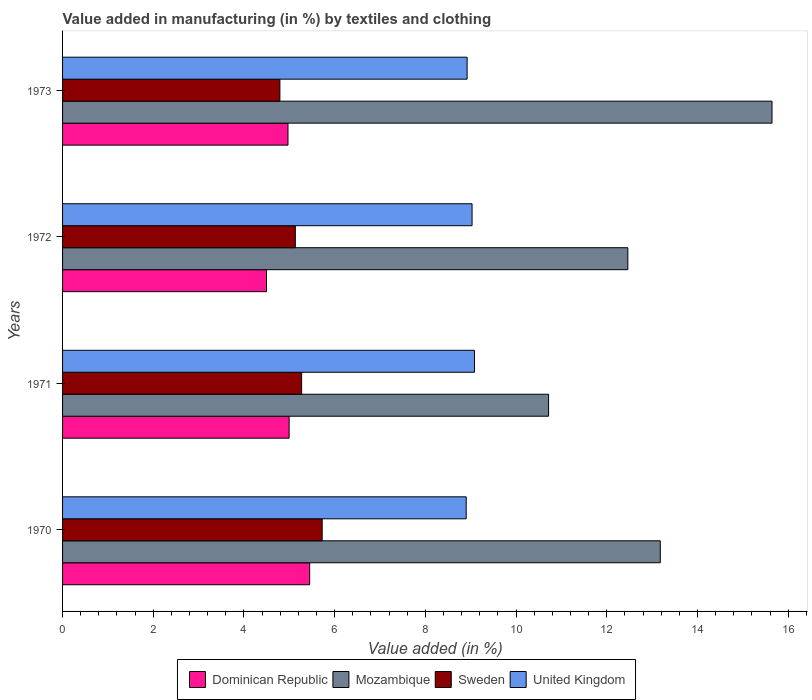How many different coloured bars are there?
Provide a succinct answer. 4. How many groups of bars are there?
Make the answer very short. 4. Are the number of bars per tick equal to the number of legend labels?
Offer a very short reply. Yes. Are the number of bars on each tick of the Y-axis equal?
Provide a succinct answer. Yes. What is the percentage of value added in manufacturing by textiles and clothing in Mozambique in 1972?
Ensure brevity in your answer.  12.46. Across all years, what is the maximum percentage of value added in manufacturing by textiles and clothing in United Kingdom?
Ensure brevity in your answer.  9.08. Across all years, what is the minimum percentage of value added in manufacturing by textiles and clothing in Mozambique?
Keep it short and to the point. 10.72. What is the total percentage of value added in manufacturing by textiles and clothing in Sweden in the graph?
Your answer should be compact. 20.92. What is the difference between the percentage of value added in manufacturing by textiles and clothing in United Kingdom in 1972 and that in 1973?
Your answer should be very brief. 0.11. What is the difference between the percentage of value added in manufacturing by textiles and clothing in United Kingdom in 1971 and the percentage of value added in manufacturing by textiles and clothing in Mozambique in 1972?
Give a very brief answer. -3.38. What is the average percentage of value added in manufacturing by textiles and clothing in United Kingdom per year?
Provide a succinct answer. 8.98. In the year 1970, what is the difference between the percentage of value added in manufacturing by textiles and clothing in Mozambique and percentage of value added in manufacturing by textiles and clothing in United Kingdom?
Ensure brevity in your answer.  4.28. In how many years, is the percentage of value added in manufacturing by textiles and clothing in Mozambique greater than 6 %?
Give a very brief answer. 4. What is the ratio of the percentage of value added in manufacturing by textiles and clothing in Mozambique in 1971 to that in 1972?
Your response must be concise. 0.86. What is the difference between the highest and the second highest percentage of value added in manufacturing by textiles and clothing in Dominican Republic?
Offer a very short reply. 0.45. What is the difference between the highest and the lowest percentage of value added in manufacturing by textiles and clothing in Sweden?
Your answer should be compact. 0.93. What does the 1st bar from the bottom in 1970 represents?
Give a very brief answer. Dominican Republic. Is it the case that in every year, the sum of the percentage of value added in manufacturing by textiles and clothing in Dominican Republic and percentage of value added in manufacturing by textiles and clothing in Sweden is greater than the percentage of value added in manufacturing by textiles and clothing in Mozambique?
Give a very brief answer. No. Are all the bars in the graph horizontal?
Ensure brevity in your answer.  Yes. How many years are there in the graph?
Ensure brevity in your answer.  4. Are the values on the major ticks of X-axis written in scientific E-notation?
Offer a terse response. No. Does the graph contain grids?
Provide a short and direct response. No. How many legend labels are there?
Provide a succinct answer. 4. How are the legend labels stacked?
Your answer should be compact. Horizontal. What is the title of the graph?
Give a very brief answer. Value added in manufacturing (in %) by textiles and clothing. What is the label or title of the X-axis?
Give a very brief answer. Value added (in %). What is the Value added (in %) in Dominican Republic in 1970?
Offer a terse response. 5.45. What is the Value added (in %) of Mozambique in 1970?
Give a very brief answer. 13.18. What is the Value added (in %) of Sweden in 1970?
Provide a succinct answer. 5.72. What is the Value added (in %) in United Kingdom in 1970?
Provide a succinct answer. 8.9. What is the Value added (in %) in Dominican Republic in 1971?
Keep it short and to the point. 5. What is the Value added (in %) in Mozambique in 1971?
Keep it short and to the point. 10.72. What is the Value added (in %) of Sweden in 1971?
Give a very brief answer. 5.27. What is the Value added (in %) in United Kingdom in 1971?
Make the answer very short. 9.08. What is the Value added (in %) of Dominican Republic in 1972?
Provide a succinct answer. 4.5. What is the Value added (in %) in Mozambique in 1972?
Offer a very short reply. 12.46. What is the Value added (in %) of Sweden in 1972?
Make the answer very short. 5.13. What is the Value added (in %) in United Kingdom in 1972?
Offer a terse response. 9.03. What is the Value added (in %) in Dominican Republic in 1973?
Offer a very short reply. 4.97. What is the Value added (in %) in Mozambique in 1973?
Your response must be concise. 15.64. What is the Value added (in %) of Sweden in 1973?
Offer a terse response. 4.79. What is the Value added (in %) in United Kingdom in 1973?
Make the answer very short. 8.92. Across all years, what is the maximum Value added (in %) of Dominican Republic?
Offer a very short reply. 5.45. Across all years, what is the maximum Value added (in %) of Mozambique?
Provide a short and direct response. 15.64. Across all years, what is the maximum Value added (in %) of Sweden?
Provide a short and direct response. 5.72. Across all years, what is the maximum Value added (in %) in United Kingdom?
Provide a short and direct response. 9.08. Across all years, what is the minimum Value added (in %) of Dominican Republic?
Keep it short and to the point. 4.5. Across all years, what is the minimum Value added (in %) in Mozambique?
Offer a terse response. 10.72. Across all years, what is the minimum Value added (in %) of Sweden?
Your answer should be compact. 4.79. Across all years, what is the minimum Value added (in %) of United Kingdom?
Provide a short and direct response. 8.9. What is the total Value added (in %) in Dominican Republic in the graph?
Ensure brevity in your answer.  19.91. What is the total Value added (in %) in Mozambique in the graph?
Your response must be concise. 52. What is the total Value added (in %) in Sweden in the graph?
Offer a terse response. 20.92. What is the total Value added (in %) of United Kingdom in the graph?
Keep it short and to the point. 35.93. What is the difference between the Value added (in %) in Dominican Republic in 1970 and that in 1971?
Your answer should be very brief. 0.45. What is the difference between the Value added (in %) in Mozambique in 1970 and that in 1971?
Offer a very short reply. 2.46. What is the difference between the Value added (in %) in Sweden in 1970 and that in 1971?
Your answer should be compact. 0.45. What is the difference between the Value added (in %) in United Kingdom in 1970 and that in 1971?
Your answer should be compact. -0.18. What is the difference between the Value added (in %) in Dominican Republic in 1970 and that in 1972?
Your response must be concise. 0.95. What is the difference between the Value added (in %) of Mozambique in 1970 and that in 1972?
Provide a succinct answer. 0.71. What is the difference between the Value added (in %) in Sweden in 1970 and that in 1972?
Offer a very short reply. 0.59. What is the difference between the Value added (in %) of United Kingdom in 1970 and that in 1972?
Your answer should be compact. -0.13. What is the difference between the Value added (in %) in Dominican Republic in 1970 and that in 1973?
Provide a succinct answer. 0.48. What is the difference between the Value added (in %) in Mozambique in 1970 and that in 1973?
Offer a terse response. -2.46. What is the difference between the Value added (in %) in Sweden in 1970 and that in 1973?
Ensure brevity in your answer.  0.93. What is the difference between the Value added (in %) in United Kingdom in 1970 and that in 1973?
Offer a terse response. -0.02. What is the difference between the Value added (in %) in Dominican Republic in 1971 and that in 1972?
Make the answer very short. 0.5. What is the difference between the Value added (in %) of Mozambique in 1971 and that in 1972?
Your answer should be compact. -1.75. What is the difference between the Value added (in %) in Sweden in 1971 and that in 1972?
Make the answer very short. 0.14. What is the difference between the Value added (in %) of United Kingdom in 1971 and that in 1972?
Provide a succinct answer. 0.05. What is the difference between the Value added (in %) in Dominican Republic in 1971 and that in 1973?
Your answer should be compact. 0.03. What is the difference between the Value added (in %) of Mozambique in 1971 and that in 1973?
Keep it short and to the point. -4.93. What is the difference between the Value added (in %) of Sweden in 1971 and that in 1973?
Make the answer very short. 0.48. What is the difference between the Value added (in %) of United Kingdom in 1971 and that in 1973?
Ensure brevity in your answer.  0.16. What is the difference between the Value added (in %) in Dominican Republic in 1972 and that in 1973?
Ensure brevity in your answer.  -0.47. What is the difference between the Value added (in %) in Mozambique in 1972 and that in 1973?
Provide a short and direct response. -3.18. What is the difference between the Value added (in %) of Sweden in 1972 and that in 1973?
Offer a terse response. 0.34. What is the difference between the Value added (in %) of United Kingdom in 1972 and that in 1973?
Your answer should be compact. 0.11. What is the difference between the Value added (in %) of Dominican Republic in 1970 and the Value added (in %) of Mozambique in 1971?
Offer a very short reply. -5.27. What is the difference between the Value added (in %) of Dominican Republic in 1970 and the Value added (in %) of Sweden in 1971?
Your answer should be very brief. 0.18. What is the difference between the Value added (in %) in Dominican Republic in 1970 and the Value added (in %) in United Kingdom in 1971?
Ensure brevity in your answer.  -3.63. What is the difference between the Value added (in %) in Mozambique in 1970 and the Value added (in %) in Sweden in 1971?
Provide a succinct answer. 7.91. What is the difference between the Value added (in %) of Mozambique in 1970 and the Value added (in %) of United Kingdom in 1971?
Keep it short and to the point. 4.1. What is the difference between the Value added (in %) in Sweden in 1970 and the Value added (in %) in United Kingdom in 1971?
Make the answer very short. -3.36. What is the difference between the Value added (in %) in Dominican Republic in 1970 and the Value added (in %) in Mozambique in 1972?
Your answer should be very brief. -7.02. What is the difference between the Value added (in %) in Dominican Republic in 1970 and the Value added (in %) in Sweden in 1972?
Provide a short and direct response. 0.32. What is the difference between the Value added (in %) in Dominican Republic in 1970 and the Value added (in %) in United Kingdom in 1972?
Give a very brief answer. -3.58. What is the difference between the Value added (in %) of Mozambique in 1970 and the Value added (in %) of Sweden in 1972?
Provide a short and direct response. 8.05. What is the difference between the Value added (in %) in Mozambique in 1970 and the Value added (in %) in United Kingdom in 1972?
Provide a short and direct response. 4.15. What is the difference between the Value added (in %) of Sweden in 1970 and the Value added (in %) of United Kingdom in 1972?
Provide a short and direct response. -3.3. What is the difference between the Value added (in %) of Dominican Republic in 1970 and the Value added (in %) of Mozambique in 1973?
Keep it short and to the point. -10.19. What is the difference between the Value added (in %) of Dominican Republic in 1970 and the Value added (in %) of Sweden in 1973?
Your answer should be compact. 0.66. What is the difference between the Value added (in %) of Dominican Republic in 1970 and the Value added (in %) of United Kingdom in 1973?
Give a very brief answer. -3.47. What is the difference between the Value added (in %) of Mozambique in 1970 and the Value added (in %) of Sweden in 1973?
Ensure brevity in your answer.  8.39. What is the difference between the Value added (in %) of Mozambique in 1970 and the Value added (in %) of United Kingdom in 1973?
Provide a succinct answer. 4.26. What is the difference between the Value added (in %) in Sweden in 1970 and the Value added (in %) in United Kingdom in 1973?
Your response must be concise. -3.2. What is the difference between the Value added (in %) in Dominican Republic in 1971 and the Value added (in %) in Mozambique in 1972?
Your response must be concise. -7.47. What is the difference between the Value added (in %) in Dominican Republic in 1971 and the Value added (in %) in Sweden in 1972?
Make the answer very short. -0.14. What is the difference between the Value added (in %) of Dominican Republic in 1971 and the Value added (in %) of United Kingdom in 1972?
Provide a succinct answer. -4.03. What is the difference between the Value added (in %) of Mozambique in 1971 and the Value added (in %) of Sweden in 1972?
Give a very brief answer. 5.58. What is the difference between the Value added (in %) of Mozambique in 1971 and the Value added (in %) of United Kingdom in 1972?
Offer a very short reply. 1.69. What is the difference between the Value added (in %) in Sweden in 1971 and the Value added (in %) in United Kingdom in 1972?
Your answer should be compact. -3.76. What is the difference between the Value added (in %) in Dominican Republic in 1971 and the Value added (in %) in Mozambique in 1973?
Offer a terse response. -10.65. What is the difference between the Value added (in %) of Dominican Republic in 1971 and the Value added (in %) of Sweden in 1973?
Your answer should be very brief. 0.2. What is the difference between the Value added (in %) in Dominican Republic in 1971 and the Value added (in %) in United Kingdom in 1973?
Your answer should be compact. -3.92. What is the difference between the Value added (in %) in Mozambique in 1971 and the Value added (in %) in Sweden in 1973?
Keep it short and to the point. 5.92. What is the difference between the Value added (in %) in Mozambique in 1971 and the Value added (in %) in United Kingdom in 1973?
Ensure brevity in your answer.  1.8. What is the difference between the Value added (in %) of Sweden in 1971 and the Value added (in %) of United Kingdom in 1973?
Provide a short and direct response. -3.65. What is the difference between the Value added (in %) in Dominican Republic in 1972 and the Value added (in %) in Mozambique in 1973?
Give a very brief answer. -11.15. What is the difference between the Value added (in %) in Dominican Republic in 1972 and the Value added (in %) in Sweden in 1973?
Provide a short and direct response. -0.29. What is the difference between the Value added (in %) of Dominican Republic in 1972 and the Value added (in %) of United Kingdom in 1973?
Your response must be concise. -4.42. What is the difference between the Value added (in %) of Mozambique in 1972 and the Value added (in %) of Sweden in 1973?
Offer a very short reply. 7.67. What is the difference between the Value added (in %) of Mozambique in 1972 and the Value added (in %) of United Kingdom in 1973?
Your answer should be compact. 3.54. What is the difference between the Value added (in %) in Sweden in 1972 and the Value added (in %) in United Kingdom in 1973?
Give a very brief answer. -3.79. What is the average Value added (in %) in Dominican Republic per year?
Your answer should be very brief. 4.98. What is the average Value added (in %) in Mozambique per year?
Make the answer very short. 13. What is the average Value added (in %) of Sweden per year?
Make the answer very short. 5.23. What is the average Value added (in %) of United Kingdom per year?
Offer a terse response. 8.98. In the year 1970, what is the difference between the Value added (in %) of Dominican Republic and Value added (in %) of Mozambique?
Your answer should be compact. -7.73. In the year 1970, what is the difference between the Value added (in %) in Dominican Republic and Value added (in %) in Sweden?
Provide a short and direct response. -0.28. In the year 1970, what is the difference between the Value added (in %) of Dominican Republic and Value added (in %) of United Kingdom?
Offer a very short reply. -3.45. In the year 1970, what is the difference between the Value added (in %) of Mozambique and Value added (in %) of Sweden?
Your answer should be very brief. 7.45. In the year 1970, what is the difference between the Value added (in %) in Mozambique and Value added (in %) in United Kingdom?
Provide a short and direct response. 4.28. In the year 1970, what is the difference between the Value added (in %) in Sweden and Value added (in %) in United Kingdom?
Keep it short and to the point. -3.18. In the year 1971, what is the difference between the Value added (in %) in Dominican Republic and Value added (in %) in Mozambique?
Keep it short and to the point. -5.72. In the year 1971, what is the difference between the Value added (in %) in Dominican Republic and Value added (in %) in Sweden?
Your answer should be very brief. -0.28. In the year 1971, what is the difference between the Value added (in %) of Dominican Republic and Value added (in %) of United Kingdom?
Make the answer very short. -4.09. In the year 1971, what is the difference between the Value added (in %) in Mozambique and Value added (in %) in Sweden?
Give a very brief answer. 5.45. In the year 1971, what is the difference between the Value added (in %) in Mozambique and Value added (in %) in United Kingdom?
Offer a terse response. 1.63. In the year 1971, what is the difference between the Value added (in %) in Sweden and Value added (in %) in United Kingdom?
Provide a succinct answer. -3.81. In the year 1972, what is the difference between the Value added (in %) in Dominican Republic and Value added (in %) in Mozambique?
Offer a very short reply. -7.97. In the year 1972, what is the difference between the Value added (in %) of Dominican Republic and Value added (in %) of Sweden?
Provide a short and direct response. -0.64. In the year 1972, what is the difference between the Value added (in %) in Dominican Republic and Value added (in %) in United Kingdom?
Offer a terse response. -4.53. In the year 1972, what is the difference between the Value added (in %) of Mozambique and Value added (in %) of Sweden?
Offer a terse response. 7.33. In the year 1972, what is the difference between the Value added (in %) in Mozambique and Value added (in %) in United Kingdom?
Keep it short and to the point. 3.44. In the year 1972, what is the difference between the Value added (in %) in Sweden and Value added (in %) in United Kingdom?
Your response must be concise. -3.9. In the year 1973, what is the difference between the Value added (in %) of Dominican Republic and Value added (in %) of Mozambique?
Provide a short and direct response. -10.67. In the year 1973, what is the difference between the Value added (in %) in Dominican Republic and Value added (in %) in Sweden?
Give a very brief answer. 0.18. In the year 1973, what is the difference between the Value added (in %) of Dominican Republic and Value added (in %) of United Kingdom?
Ensure brevity in your answer.  -3.95. In the year 1973, what is the difference between the Value added (in %) in Mozambique and Value added (in %) in Sweden?
Ensure brevity in your answer.  10.85. In the year 1973, what is the difference between the Value added (in %) in Mozambique and Value added (in %) in United Kingdom?
Offer a terse response. 6.72. In the year 1973, what is the difference between the Value added (in %) of Sweden and Value added (in %) of United Kingdom?
Your answer should be compact. -4.13. What is the ratio of the Value added (in %) in Dominican Republic in 1970 to that in 1971?
Give a very brief answer. 1.09. What is the ratio of the Value added (in %) in Mozambique in 1970 to that in 1971?
Your answer should be very brief. 1.23. What is the ratio of the Value added (in %) of Sweden in 1970 to that in 1971?
Provide a succinct answer. 1.09. What is the ratio of the Value added (in %) of Dominican Republic in 1970 to that in 1972?
Your response must be concise. 1.21. What is the ratio of the Value added (in %) of Mozambique in 1970 to that in 1972?
Keep it short and to the point. 1.06. What is the ratio of the Value added (in %) of Sweden in 1970 to that in 1972?
Give a very brief answer. 1.12. What is the ratio of the Value added (in %) in United Kingdom in 1970 to that in 1972?
Provide a short and direct response. 0.99. What is the ratio of the Value added (in %) in Dominican Republic in 1970 to that in 1973?
Provide a short and direct response. 1.1. What is the ratio of the Value added (in %) of Mozambique in 1970 to that in 1973?
Make the answer very short. 0.84. What is the ratio of the Value added (in %) in Sweden in 1970 to that in 1973?
Offer a very short reply. 1.19. What is the ratio of the Value added (in %) of United Kingdom in 1970 to that in 1973?
Ensure brevity in your answer.  1. What is the ratio of the Value added (in %) of Dominican Republic in 1971 to that in 1972?
Offer a terse response. 1.11. What is the ratio of the Value added (in %) of Mozambique in 1971 to that in 1972?
Keep it short and to the point. 0.86. What is the ratio of the Value added (in %) in United Kingdom in 1971 to that in 1972?
Your answer should be compact. 1.01. What is the ratio of the Value added (in %) of Mozambique in 1971 to that in 1973?
Keep it short and to the point. 0.69. What is the ratio of the Value added (in %) of Sweden in 1971 to that in 1973?
Ensure brevity in your answer.  1.1. What is the ratio of the Value added (in %) of United Kingdom in 1971 to that in 1973?
Make the answer very short. 1.02. What is the ratio of the Value added (in %) in Dominican Republic in 1972 to that in 1973?
Your answer should be compact. 0.9. What is the ratio of the Value added (in %) of Mozambique in 1972 to that in 1973?
Provide a short and direct response. 0.8. What is the ratio of the Value added (in %) in Sweden in 1972 to that in 1973?
Ensure brevity in your answer.  1.07. What is the ratio of the Value added (in %) of United Kingdom in 1972 to that in 1973?
Offer a very short reply. 1.01. What is the difference between the highest and the second highest Value added (in %) of Dominican Republic?
Keep it short and to the point. 0.45. What is the difference between the highest and the second highest Value added (in %) of Mozambique?
Your answer should be compact. 2.46. What is the difference between the highest and the second highest Value added (in %) of Sweden?
Your answer should be compact. 0.45. What is the difference between the highest and the second highest Value added (in %) of United Kingdom?
Give a very brief answer. 0.05. What is the difference between the highest and the lowest Value added (in %) in Dominican Republic?
Offer a very short reply. 0.95. What is the difference between the highest and the lowest Value added (in %) of Mozambique?
Provide a short and direct response. 4.93. What is the difference between the highest and the lowest Value added (in %) of Sweden?
Give a very brief answer. 0.93. What is the difference between the highest and the lowest Value added (in %) of United Kingdom?
Offer a very short reply. 0.18. 